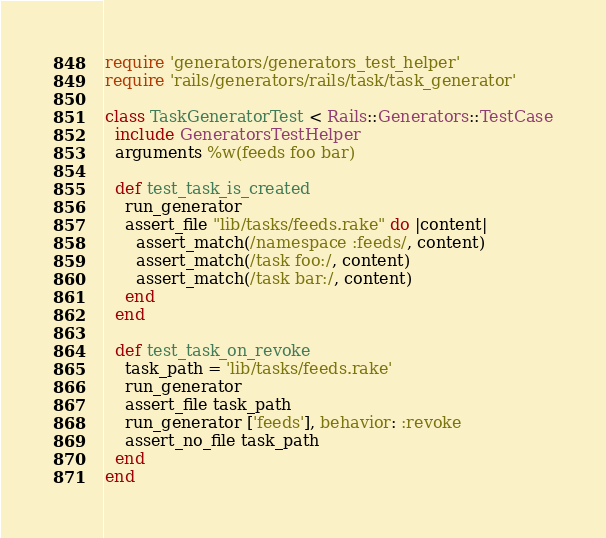<code> <loc_0><loc_0><loc_500><loc_500><_Ruby_>require 'generators/generators_test_helper'
require 'rails/generators/rails/task/task_generator'

class TaskGeneratorTest < Rails::Generators::TestCase
  include GeneratorsTestHelper
  arguments %w(feeds foo bar)

  def test_task_is_created
    run_generator
    assert_file "lib/tasks/feeds.rake" do |content|
      assert_match(/namespace :feeds/, content)
      assert_match(/task foo:/, content)
      assert_match(/task bar:/, content)
    end
  end

  def test_task_on_revoke
    task_path = 'lib/tasks/feeds.rake'
    run_generator
    assert_file task_path
    run_generator ['feeds'], behavior: :revoke
    assert_no_file task_path
  end
end
</code> 